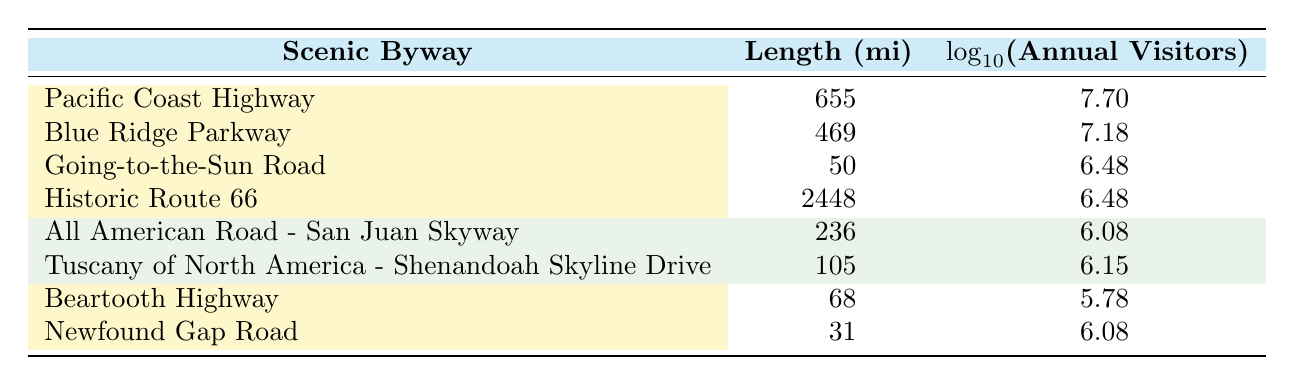What is the length in miles of the Pacific Coast Highway? The length of the Pacific Coast Highway is directly provided in the table under the "Length (mi)" column. It states 655 miles as the length for this scenic byway.
Answer: 655 Which scenic byway has the highest number of annual visitors? The table lists the annual visitors for each byway. The Pacific Coast Highway has the highest number of annual visitors at 50,000,000.
Answer: Pacific Coast Highway What is the total length of the Blue Ridge Parkway and the Going-to-the-Sun Road combined? The Blue Ridge Parkway has a length of 469 miles, and the Going-to-the-Sun Road has a length of 50 miles. Adding these together gives a total length of 469 + 50 = 519 miles.
Answer: 519 Is the length of the Historic Route 66 greater than 500 miles? The length of the Historic Route 66 is given as 2,448 miles, which is greater than 500 miles. Therefore, the statement is true.
Answer: Yes How many more annual visitors does the Blue Ridge Parkway have compared to the All American Road - San Juan Skyway? The Blue Ridge Parkway has 15,000,000 annual visitors, while the All American Road - San Juan Skyway has 1,200,000. The difference is 15,000,000 - 1,200,000 = 13,800,000.
Answer: 13,800,000 What is the average number of annual visitors across all listed scenic byways? To find the average, we sum the annual visitors: 50,000,000 + 15,000,000 + 3,000,000 + 3,000,000 + 1,200,000 + 1,400,000 + 600,000 + 1,200,000 = 76,400,000. There are 8 byways, so the average number is 76,400,000 / 8 = 9,550,000.
Answer: 9,550,000 Which byway has the lowest number of annual visitors, and what is that number? The byway with the lowest number of annual visitors is the Beartooth Highway, which has 600,000 annual visitors as per the table.
Answer: Beartooth Highway, 600,000 Are there any byways with a logarithmic value of annual visitors greater than 7? Referring to the logarithmic values provided, the Pacific Coast Highway (7.70) and the Blue Ridge Parkway (7.18) both have values greater than 7, indicating the answer is true.
Answer: Yes What is the difference in length between the longest and shortest scenic byways listed? The longest is the Historic Route 66 at 2,448 miles and the shortest is Newfound Gap Road at 31 miles. The difference in length is 2,448 - 31 = 2,417 miles.
Answer: 2,417 